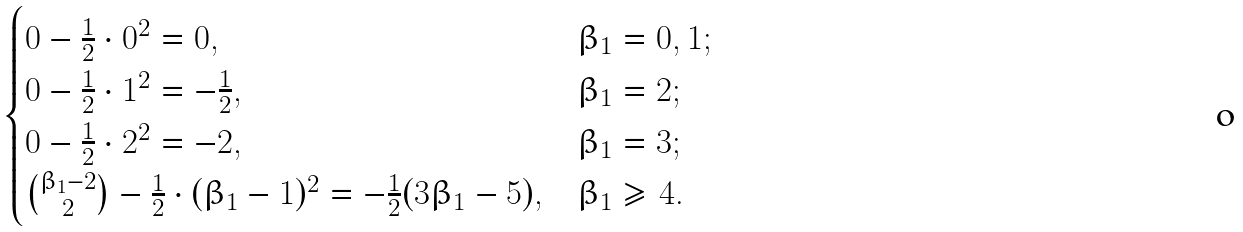<formula> <loc_0><loc_0><loc_500><loc_500>\begin{cases} 0 - \frac { 1 } { 2 } \cdot 0 ^ { 2 } = 0 , & \beta _ { 1 } = 0 , 1 ; \\ 0 - \frac { 1 } { 2 } \cdot 1 ^ { 2 } = - \frac { 1 } { 2 } , & \beta _ { 1 } = 2 ; \\ 0 - \frac { 1 } { 2 } \cdot 2 ^ { 2 } = - 2 , & \beta _ { 1 } = 3 ; \\ \binom { \beta _ { 1 } - 2 } { 2 } - \frac { 1 } { 2 } \cdot ( \beta _ { 1 } - 1 ) ^ { 2 } = - \frac { 1 } { 2 } ( 3 \beta _ { 1 } - 5 ) , & \beta _ { 1 } \geq 4 . \end{cases}</formula> 